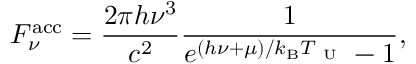Convert formula to latex. <formula><loc_0><loc_0><loc_500><loc_500>F _ { \nu } ^ { a c c } = \frac { 2 \pi h \nu ^ { 3 } } { c ^ { 2 } } \frac { 1 } { e ^ { ( h \nu + \mu ) / k _ { B } T _ { U } } - 1 } ,</formula> 